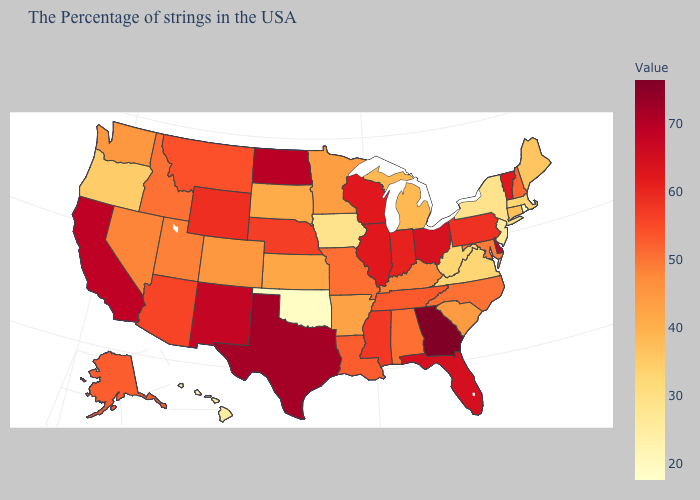Among the states that border Massachusetts , does Rhode Island have the lowest value?
Quick response, please. Yes. Among the states that border Louisiana , does Arkansas have the highest value?
Concise answer only. No. Is the legend a continuous bar?
Give a very brief answer. Yes. Among the states that border West Virginia , which have the highest value?
Keep it brief. Ohio. Among the states that border Alabama , does Mississippi have the lowest value?
Give a very brief answer. No. 